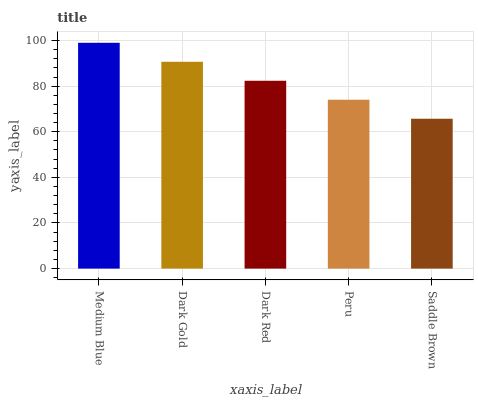Is Dark Gold the minimum?
Answer yes or no. No. Is Dark Gold the maximum?
Answer yes or no. No. Is Medium Blue greater than Dark Gold?
Answer yes or no. Yes. Is Dark Gold less than Medium Blue?
Answer yes or no. Yes. Is Dark Gold greater than Medium Blue?
Answer yes or no. No. Is Medium Blue less than Dark Gold?
Answer yes or no. No. Is Dark Red the high median?
Answer yes or no. Yes. Is Dark Red the low median?
Answer yes or no. Yes. Is Saddle Brown the high median?
Answer yes or no. No. Is Medium Blue the low median?
Answer yes or no. No. 